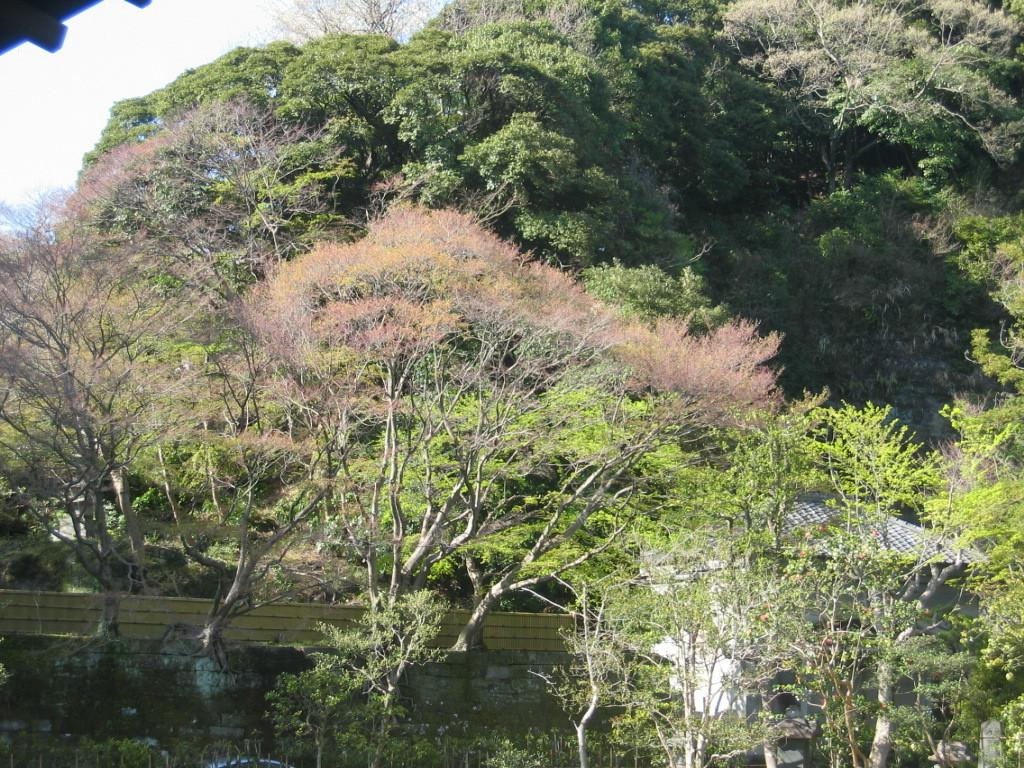What type of structure can be seen in the image? There is a house present in the image. What is located near the house? A fence is visible in the image. What can be seen in the background of the image? The sky is visible in the background of the image. How many ants can be seen carrying grapes on the fence in the image? There are no ants or grapes present in the image; it only features a house and a fence. 